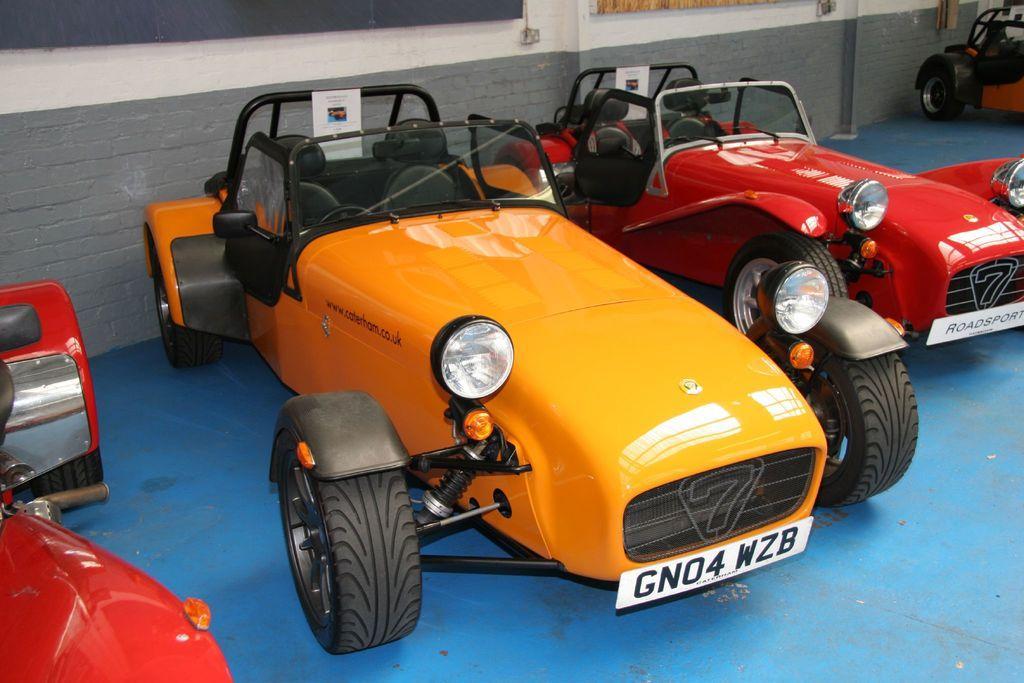In one or two sentences, can you explain what this image depicts? In this picture we can see some vehicles are parked on the path and behind the vehicles there is a wall. 